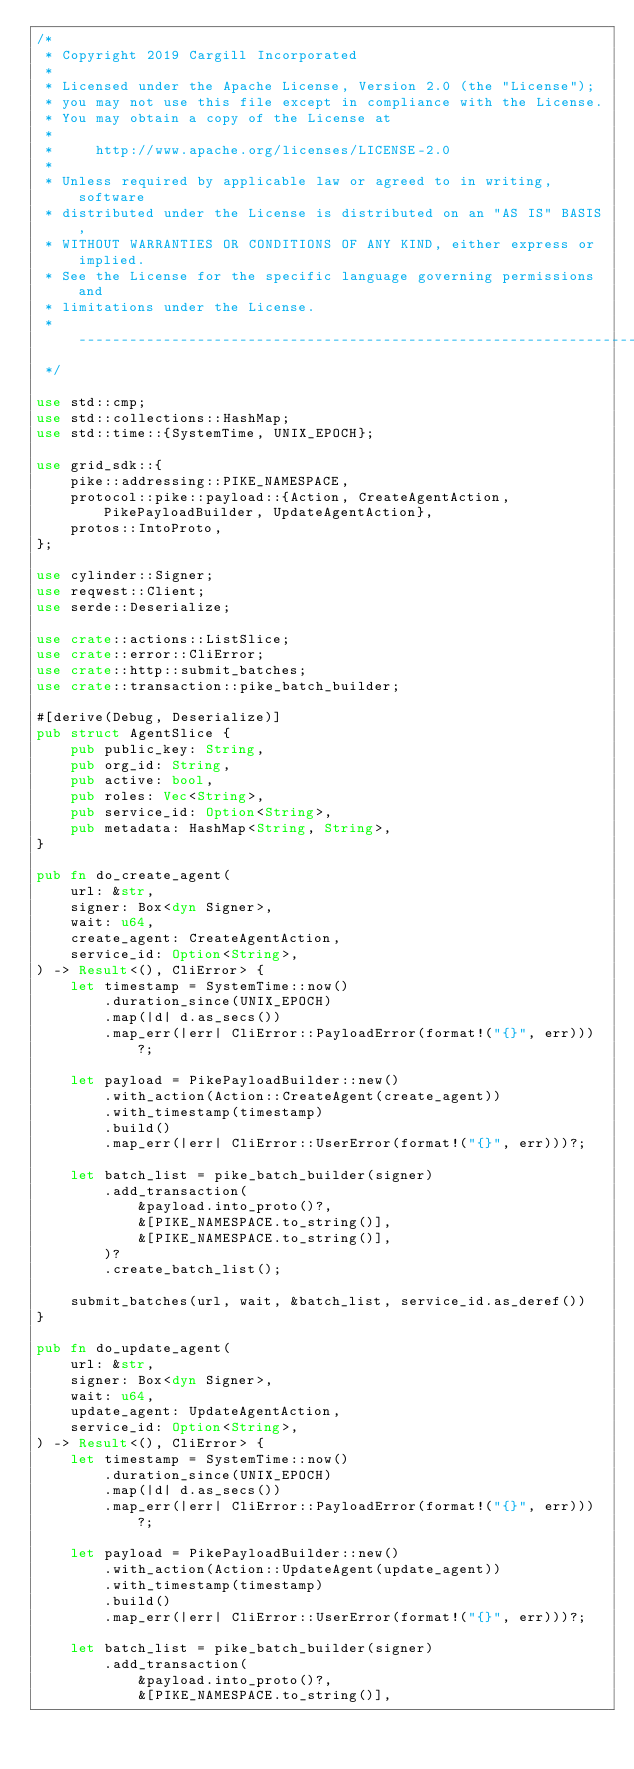<code> <loc_0><loc_0><loc_500><loc_500><_Rust_>/*
 * Copyright 2019 Cargill Incorporated
 *
 * Licensed under the Apache License, Version 2.0 (the "License");
 * you may not use this file except in compliance with the License.
 * You may obtain a copy of the License at
 *
 *     http://www.apache.org/licenses/LICENSE-2.0
 *
 * Unless required by applicable law or agreed to in writing, software
 * distributed under the License is distributed on an "AS IS" BASIS,
 * WITHOUT WARRANTIES OR CONDITIONS OF ANY KIND, either express or implied.
 * See the License for the specific language governing permissions and
 * limitations under the License.
 * -----------------------------------------------------------------------------
 */

use std::cmp;
use std::collections::HashMap;
use std::time::{SystemTime, UNIX_EPOCH};

use grid_sdk::{
    pike::addressing::PIKE_NAMESPACE,
    protocol::pike::payload::{Action, CreateAgentAction, PikePayloadBuilder, UpdateAgentAction},
    protos::IntoProto,
};

use cylinder::Signer;
use reqwest::Client;
use serde::Deserialize;

use crate::actions::ListSlice;
use crate::error::CliError;
use crate::http::submit_batches;
use crate::transaction::pike_batch_builder;

#[derive(Debug, Deserialize)]
pub struct AgentSlice {
    pub public_key: String,
    pub org_id: String,
    pub active: bool,
    pub roles: Vec<String>,
    pub service_id: Option<String>,
    pub metadata: HashMap<String, String>,
}

pub fn do_create_agent(
    url: &str,
    signer: Box<dyn Signer>,
    wait: u64,
    create_agent: CreateAgentAction,
    service_id: Option<String>,
) -> Result<(), CliError> {
    let timestamp = SystemTime::now()
        .duration_since(UNIX_EPOCH)
        .map(|d| d.as_secs())
        .map_err(|err| CliError::PayloadError(format!("{}", err)))?;

    let payload = PikePayloadBuilder::new()
        .with_action(Action::CreateAgent(create_agent))
        .with_timestamp(timestamp)
        .build()
        .map_err(|err| CliError::UserError(format!("{}", err)))?;

    let batch_list = pike_batch_builder(signer)
        .add_transaction(
            &payload.into_proto()?,
            &[PIKE_NAMESPACE.to_string()],
            &[PIKE_NAMESPACE.to_string()],
        )?
        .create_batch_list();

    submit_batches(url, wait, &batch_list, service_id.as_deref())
}

pub fn do_update_agent(
    url: &str,
    signer: Box<dyn Signer>,
    wait: u64,
    update_agent: UpdateAgentAction,
    service_id: Option<String>,
) -> Result<(), CliError> {
    let timestamp = SystemTime::now()
        .duration_since(UNIX_EPOCH)
        .map(|d| d.as_secs())
        .map_err(|err| CliError::PayloadError(format!("{}", err)))?;

    let payload = PikePayloadBuilder::new()
        .with_action(Action::UpdateAgent(update_agent))
        .with_timestamp(timestamp)
        .build()
        .map_err(|err| CliError::UserError(format!("{}", err)))?;

    let batch_list = pike_batch_builder(signer)
        .add_transaction(
            &payload.into_proto()?,
            &[PIKE_NAMESPACE.to_string()],</code> 